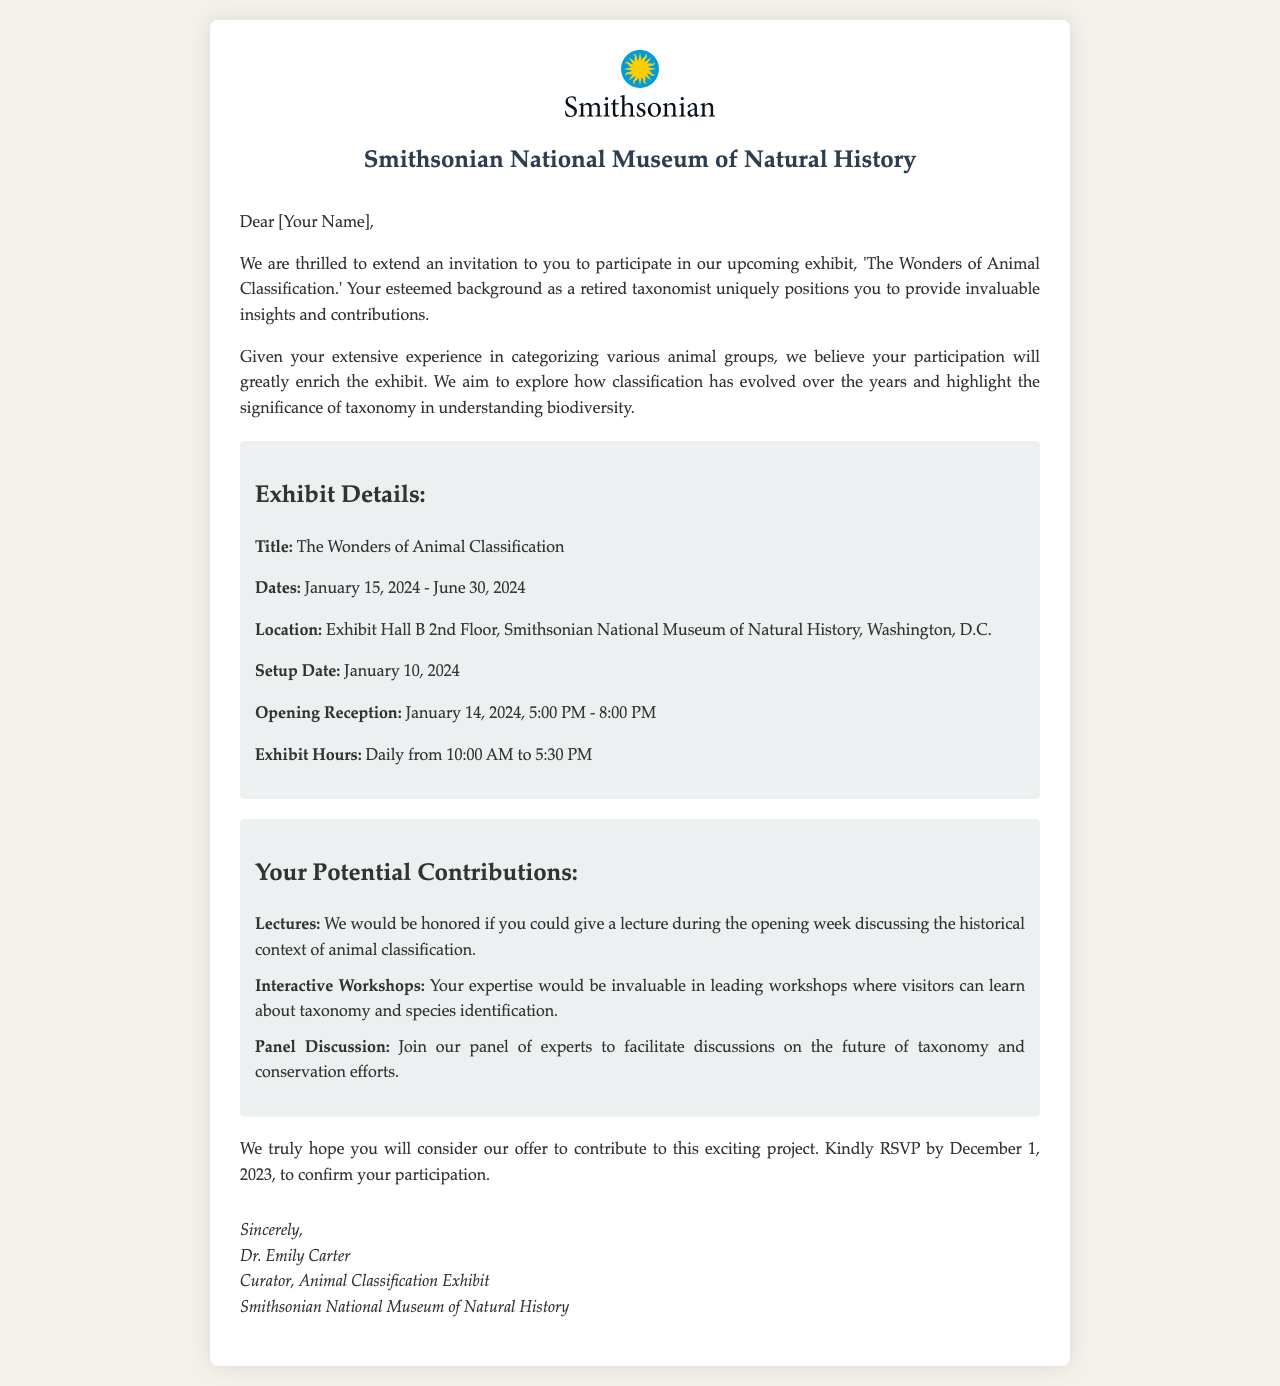What is the title of the exhibit? The title is explicitly mentioned in the exhibit details section of the document.
Answer: The Wonders of Animal Classification What is the end date of the exhibit? The document states the duration of the exhibit, including the start and end dates.
Answer: June 30, 2024 What location will the exhibit be held? The location is provided in the logistics section of the document.
Answer: Exhibit Hall B 2nd Floor, Smithsonian National Museum of Natural History, Washington, D.C When is the RSVP deadline? The deadline for responding to the invitation is clearly specified in the closing section.
Answer: December 1, 2023 What role is the invitee expected to fulfill regarding lectures? The document describes a specific contribution related to lectures within the contributions section.
Answer: Give a lecture during the opening week What is one of the interactive activities mentioned? The document outlines specific contributions, including interactive activities that the invitee could lead.
Answer: Leading workshops Who signed the letter? The signature section at the end of the letter identifies the signatory.
Answer: Dr. Emily Carter What is the opening reception date? The date of the opening reception is distinctly stated in the logistics section.
Answer: January 14, 2024 How long does the exhibit run daily? The exhibit hours are provided in the logistics section, indicating the operation schedule.
Answer: 10:00 AM to 5:30 PM 